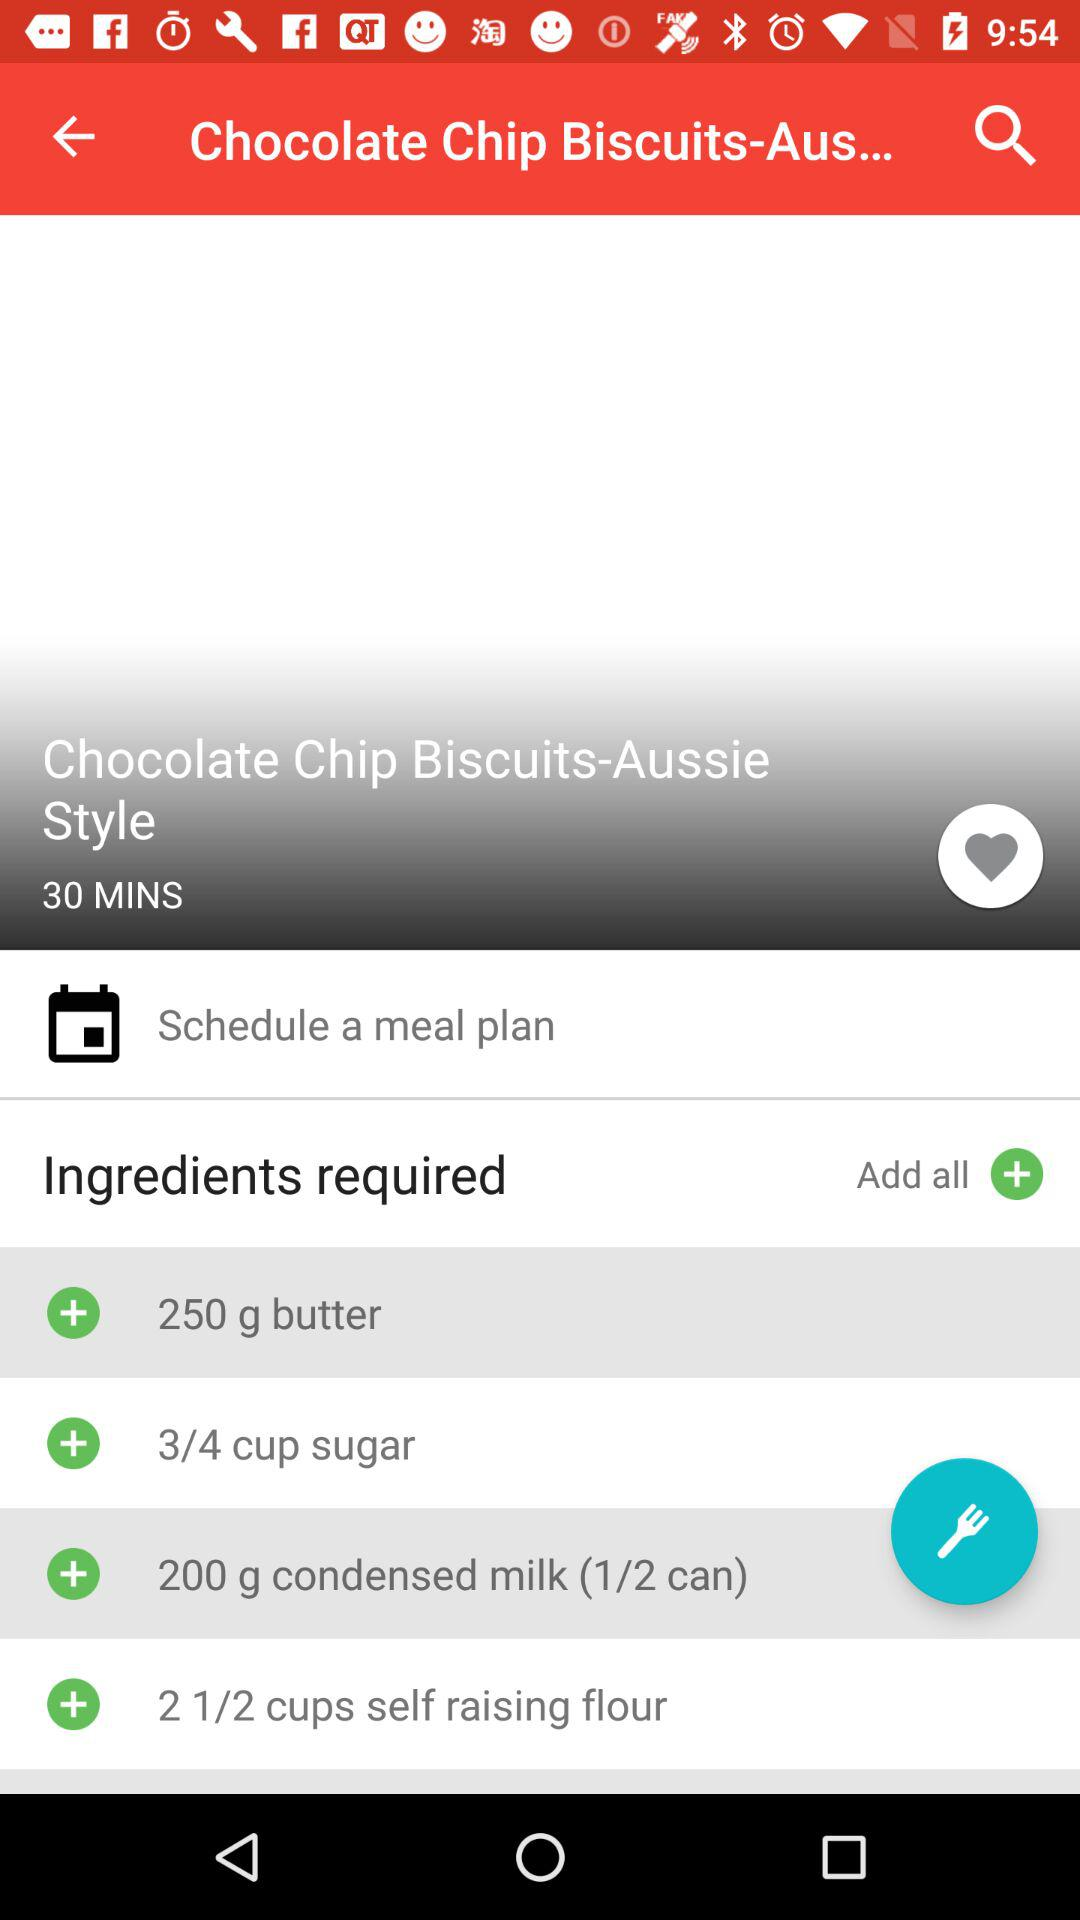How many cups of self raising flour are required? The required quantity of self raising flour is two and a half cups. 